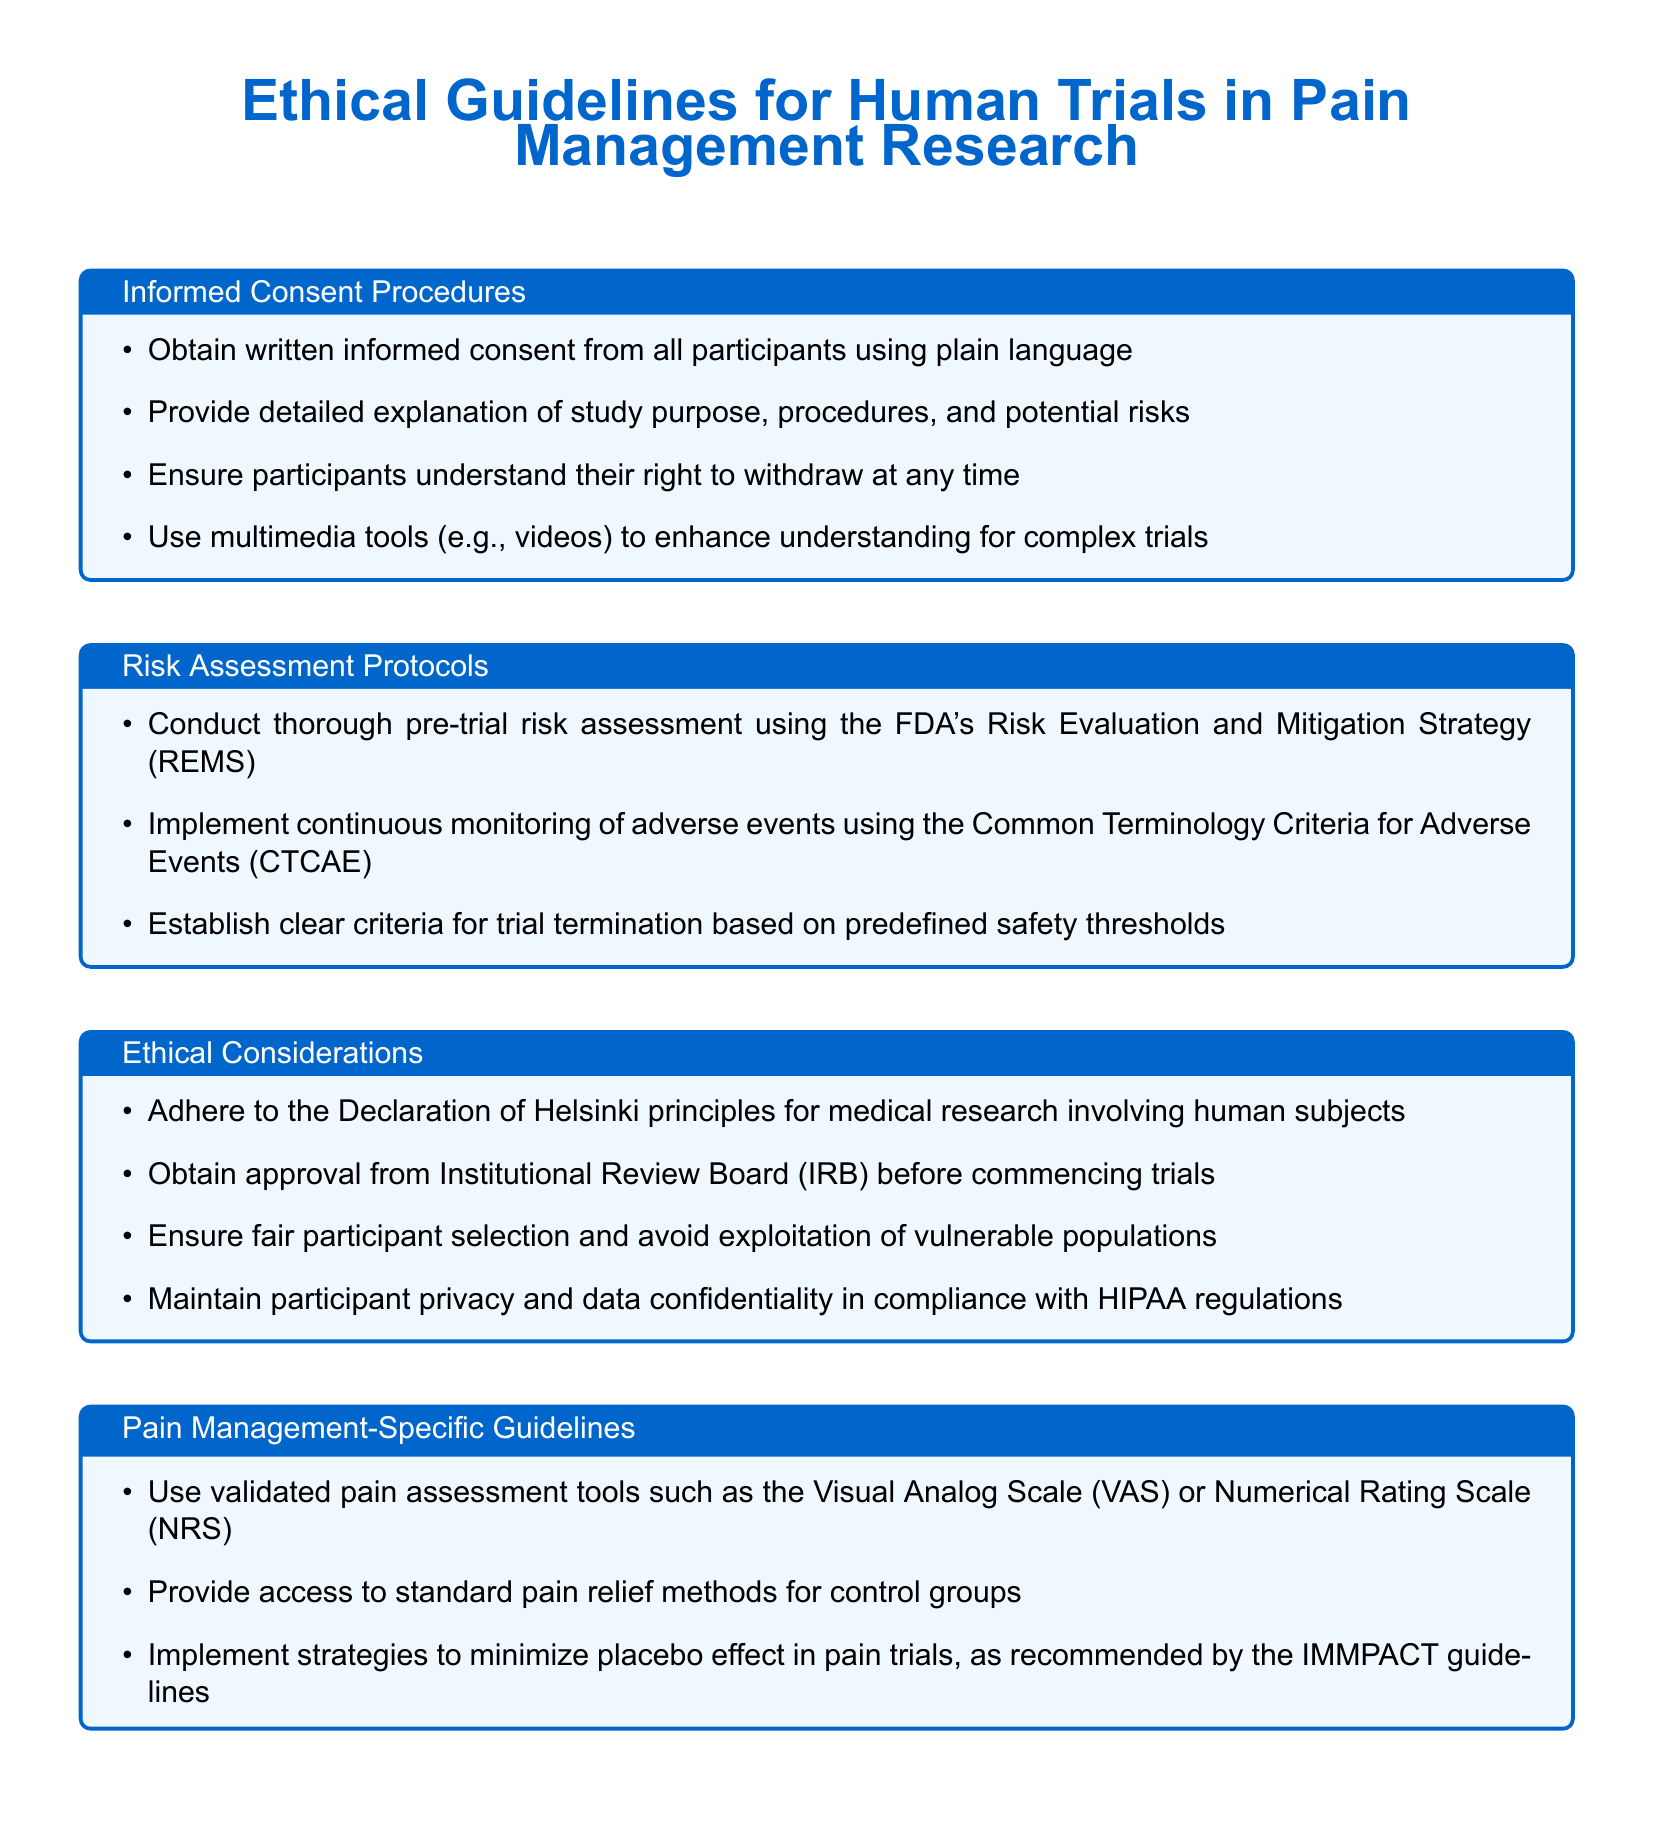What is the document's main focus? The main focus of the document is outlined in the title, which addresses ethical guidelines for conducting human trials in pain management research.
Answer: Ethical guidelines for human trials in pain management research What must be obtained from all participants before the trial? The document specifies the requirement for written informed consent from all participants.
Answer: Written informed consent Which strategy should be used for pre-trial risk assessment? The document mentions implementing the FDA's Risk Evaluation and Mitigation Strategy for thorough pre-trial risk assessment.
Answer: FDA's Risk Evaluation and Mitigation Strategy (REMS) What principles must be adhered to according to the ethical considerations? The ethical considerations section refers to the Declaration of Helsinki principles for medical research involving human subjects.
Answer: Declaration of Helsinki principles What tool is suggested for pain assessment? The document lists validated pain assessment tools such as the Visual Analog Scale or Numerical Rating Scale.
Answer: Visual Analog Scale or Numerical Rating Scale What approach enhances understanding for complex trials? According to the informed consent procedures, using multimedia tools like videos enhances understanding for complex trials.
Answer: Multimedia tools (videos) What should be established for trial termination? The risk assessment protocols state that clear criteria for trial termination should be established based on predefined safety thresholds.
Answer: Clear criteria for trial termination How should participant privacy be maintained? The ethical considerations indicate that participant privacy should be maintained in compliance with HIPAA regulations.
Answer: Compliance with HIPAA regulations What is the purpose of minimizing the placebo effect? Pain management-specific guidelines aim to implement strategies to minimize the placebo effect in pain trials, as recommended by IMMPACT guidelines.
Answer: Minimize placebo effect Which board must approve the trials before they commence? The ethical considerations section requires obtaining approval from the Institutional Review Board before commencing trials.
Answer: Institutional Review Board (IRB) 